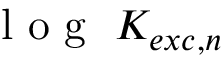<formula> <loc_0><loc_0><loc_500><loc_500>l o g K _ { e x c , n }</formula> 